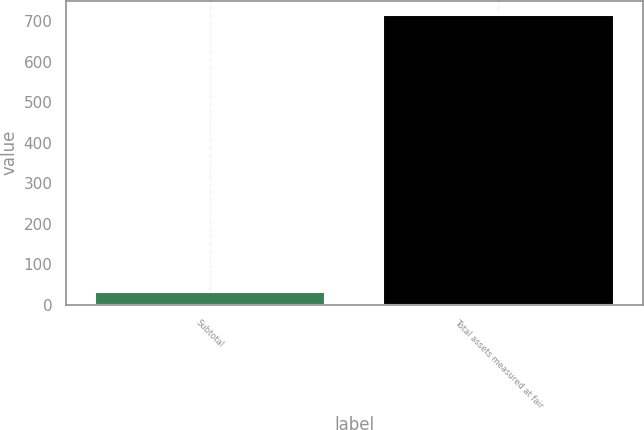Convert chart to OTSL. <chart><loc_0><loc_0><loc_500><loc_500><bar_chart><fcel>Subtotal<fcel>Total assets measured at fair<nl><fcel>30.8<fcel>714.6<nl></chart> 